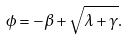<formula> <loc_0><loc_0><loc_500><loc_500>\phi = - \beta + \sqrt { \lambda + \gamma } .</formula> 